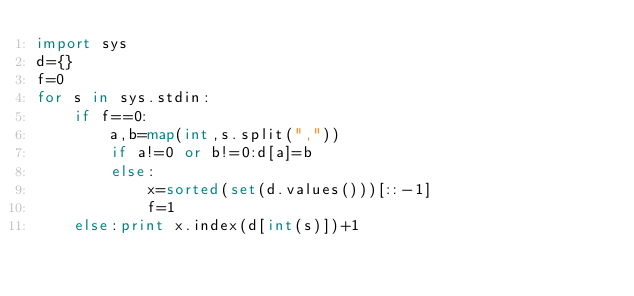<code> <loc_0><loc_0><loc_500><loc_500><_Python_>import sys
d={}
f=0
for s in sys.stdin:
    if f==0:
        a,b=map(int,s.split(","))
        if a!=0 or b!=0:d[a]=b
        else:
            x=sorted(set(d.values()))[::-1]
            f=1
    else:print x.index(d[int(s)])+1</code> 